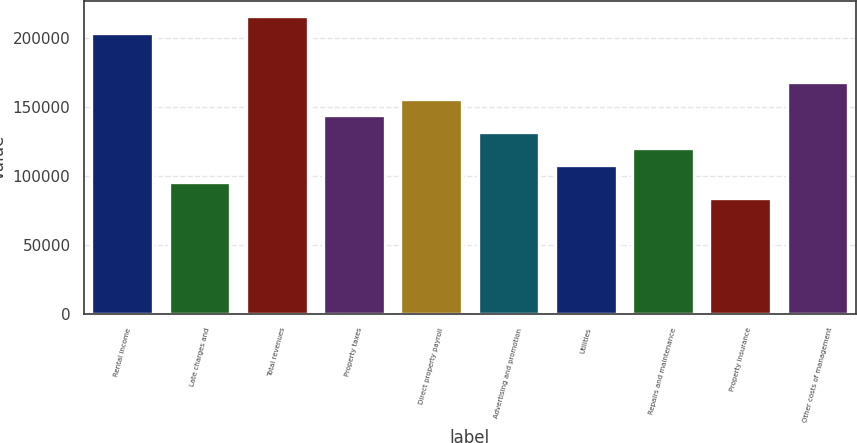<chart> <loc_0><loc_0><loc_500><loc_500><bar_chart><fcel>Rental income<fcel>Late charges and<fcel>Total revenues<fcel>Property taxes<fcel>Direct property payroll<fcel>Advertising and promotion<fcel>Utilities<fcel>Repairs and maintenance<fcel>Property insurance<fcel>Other costs of management<nl><fcel>203618<fcel>95821.1<fcel>215596<fcel>143731<fcel>155708<fcel>131753<fcel>107799<fcel>119776<fcel>83843.6<fcel>167686<nl></chart> 